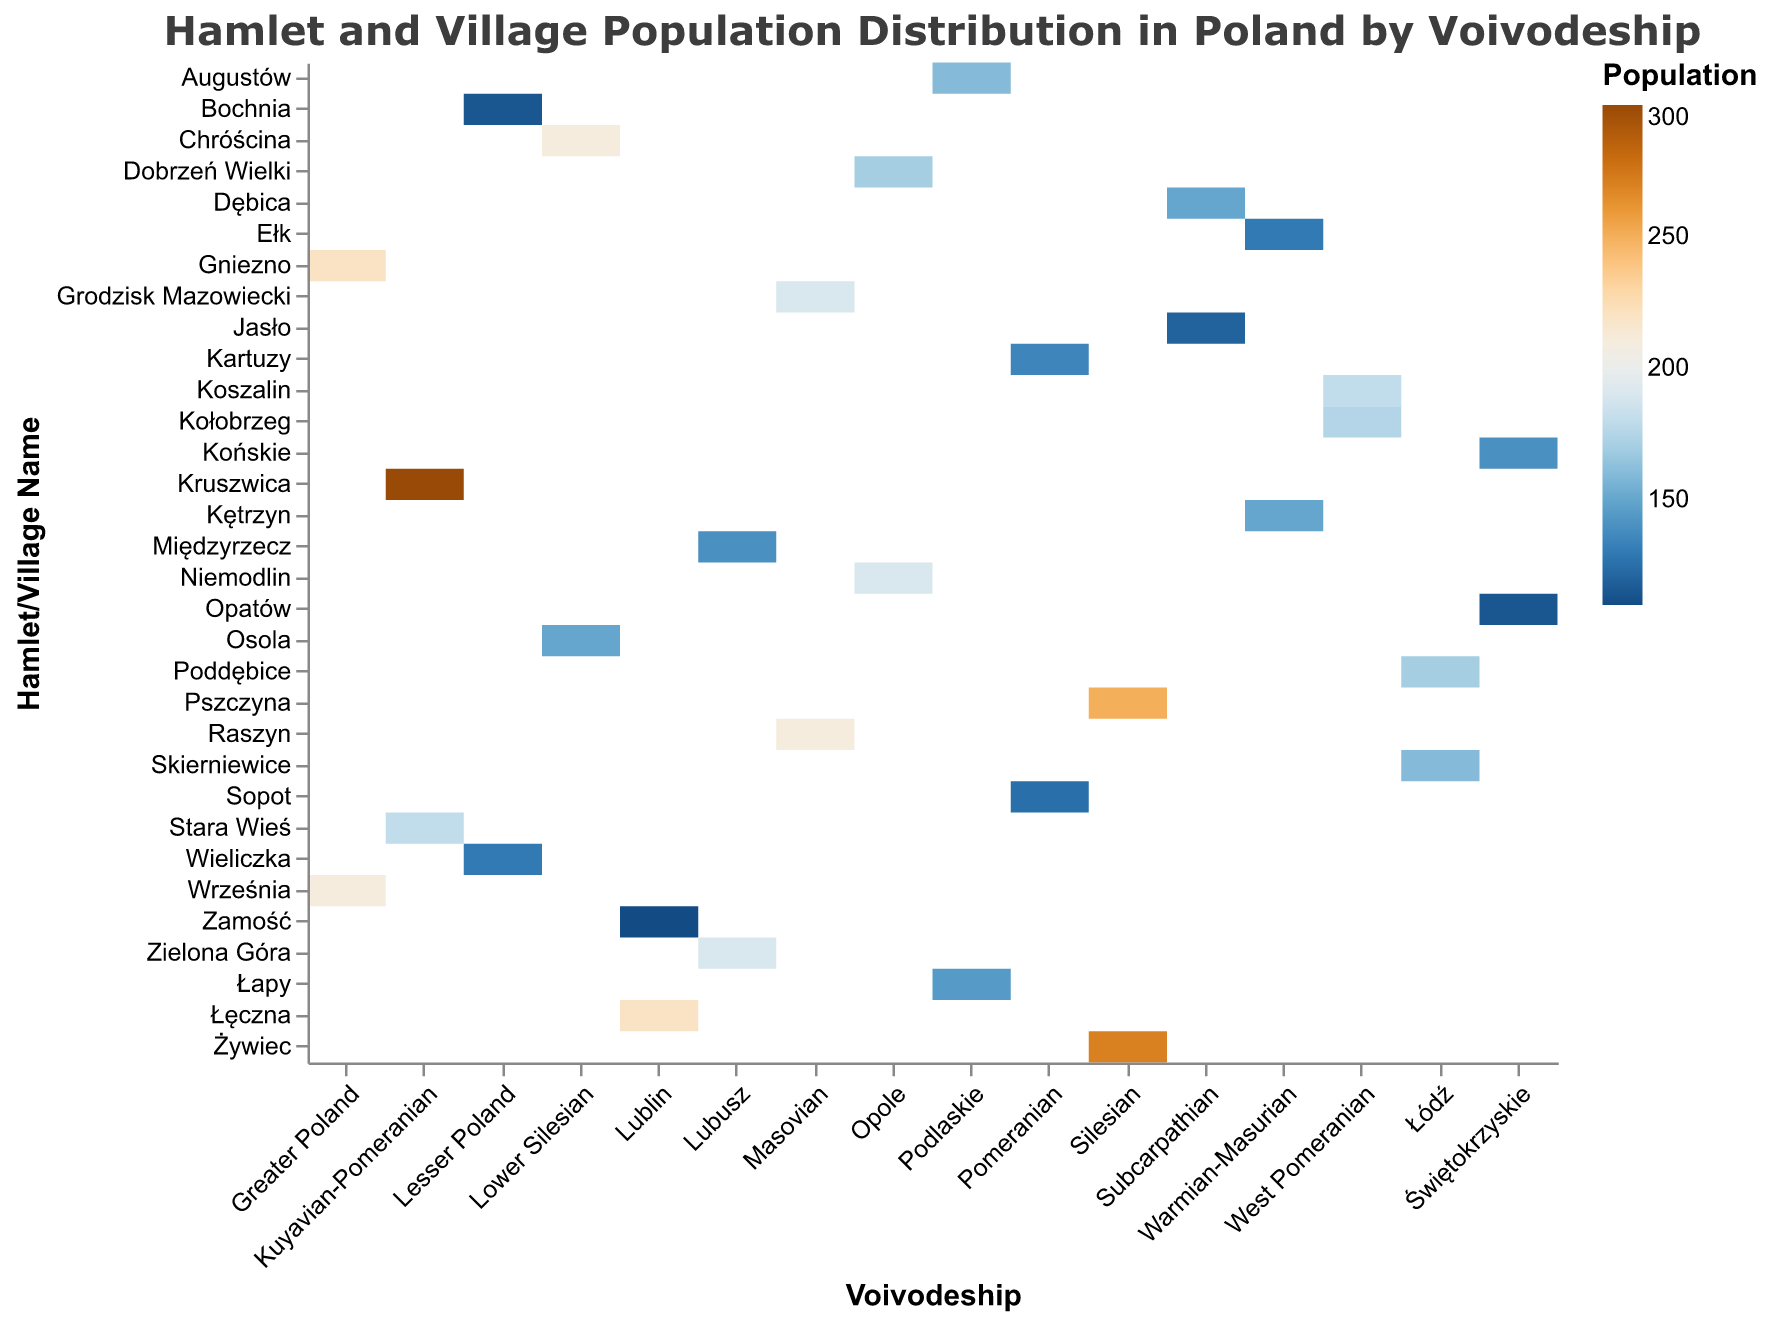What is the title of the figure? The title of the figure is usually displayed at the top. In this case, it reads "Hamlet and Village Population Distribution in Poland by Voivodeship."
Answer: Hamlet and Village Population Distribution in Poland by Voivodeship In which Voivodeship is Kruszwica located, and what is its population? Find Kruszwica on the y-axis and trace it to the corresponding Voivodeship on the x-axis. Also, check the color gradient or the tooltip for the population. Kruszwica is in the Kuyavian-Pomeranian Voivodeship, and its population is 300.
Answer: Kuyavian-Pomeranian, 300 Which village has the lowest population in the Lubusz Voivodeship? Look at the villages under the Lubusz Voivodeship on the x-axis and compare their populations based on the color intensity or tooltip information. Międzyrzecz has the lowest population in the Lubusz Voivodeship with 140 inhabitants.
Answer: Międzyrzecz, 140 Which village has the highest population among all the villages listed, and in which Voivodeship is it located? Identify the village with the darkest shade (indicating the highest population) or use the tooltip to find the village with the highest numerical value. Kruszwica has the highest population of 300 and is located in the Kuyavian-Pomeranian Voivodeship.
Answer: Kruszwica, Kuyavian-Pomeranian What is the combined population of villages in the Masovian Voivodeship? Sum up the populations of Grodzisk Mazowiecki and Raszyn, the two villages listed under the Masovian Voivodeship. 190 (Grodzisk Mazowiecki) + 210 (Raszyn) = 400.
Answer: 400 Compare the populations of Żywiec and Pszczyna in the Silesian Voivodeship. Which one is larger, and by how much? Check the population values for Żywiec and Pszczyna and subtract the smaller value from the larger value. Pszczyna has 250, and Żywiec has 270. So, 270 - 250 = 20. Żywiec's population is larger by 20.
Answer: Żywiec, 20 What is the average population of villages in the Lesser Poland Voivodeship? Calculate the average by summing the populations of Wieliczka and Bochnia, then divide by 2. (130 + 115) / 2 = 122.5.
Answer: 122.5 Which Voivodeship has more villages listed: Opole or Łódź? Count the number of villages listed for each Voivodeship. Opole has Dobrzeń Wielki and Niemodlin (2 villages), while Łódź has Skierniewice and Poddębice (2 villages as well). Both have the same number of villages listed.
Answer: Both have 2 What is the population range (difference between the maximum and minimum population) among the listed villages in West Pomeranian Voivodeship? Identify the maximum population in Koszalin (180) and the minimum in Kołobrzeg (175). The range is calculated as 180 - 175 = 5.
Answer: 5 How does the population distribution vary between the hamlets and villages in Świętokrzyskie and Warmian-Masurian Voivodeships? Compare the population values for each village in these two Voivodeships. Świętokrzyskie has populations of 115 (Opatów) and 140 (Końskie), while Warmian-Masurian has 130 (Ełk) and 150 (Kętrzyn). Populations in Świętokrzyskie range from 115 to 140, and in Warmian-Masurian, from 130 to 150.
Answer: Świętokrzyskie (115 to 140), Warmian-Masurian (130 to 150) 